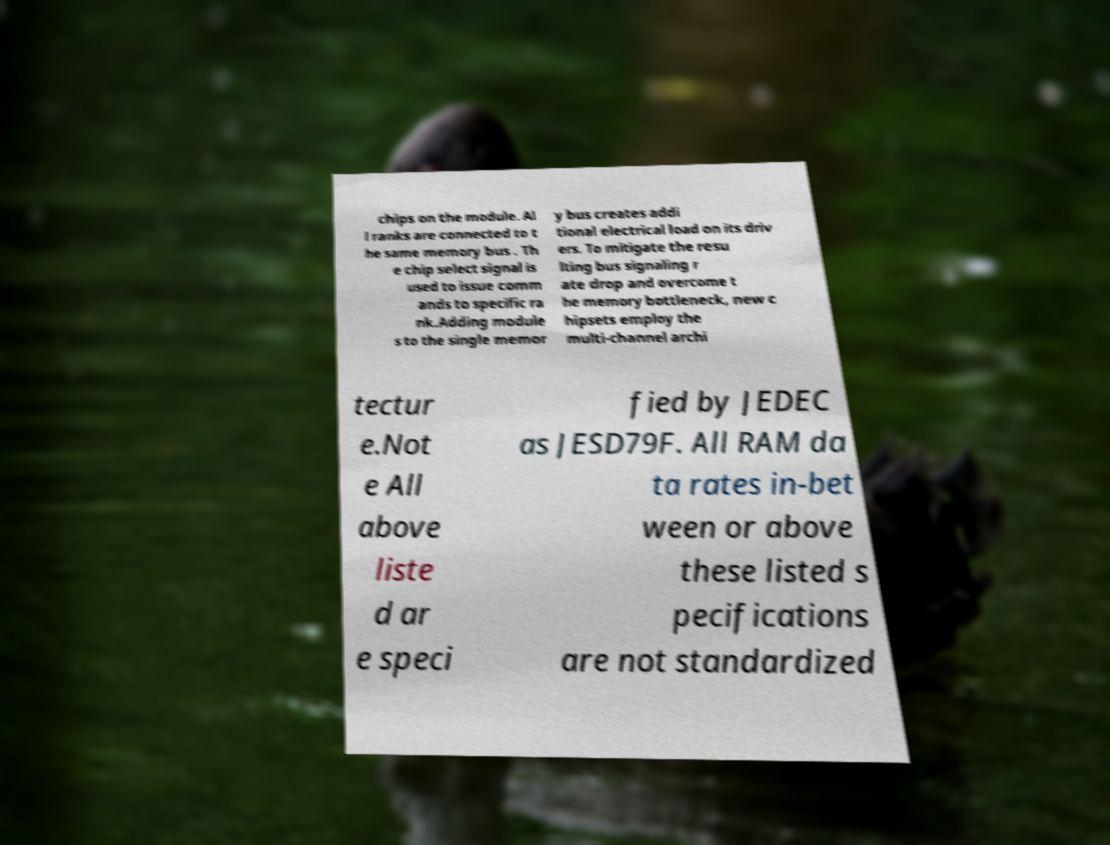Can you accurately transcribe the text from the provided image for me? chips on the module. Al l ranks are connected to t he same memory bus . Th e chip select signal is used to issue comm ands to specific ra nk.Adding module s to the single memor y bus creates addi tional electrical load on its driv ers. To mitigate the resu lting bus signaling r ate drop and overcome t he memory bottleneck, new c hipsets employ the multi-channel archi tectur e.Not e All above liste d ar e speci fied by JEDEC as JESD79F. All RAM da ta rates in-bet ween or above these listed s pecifications are not standardized 